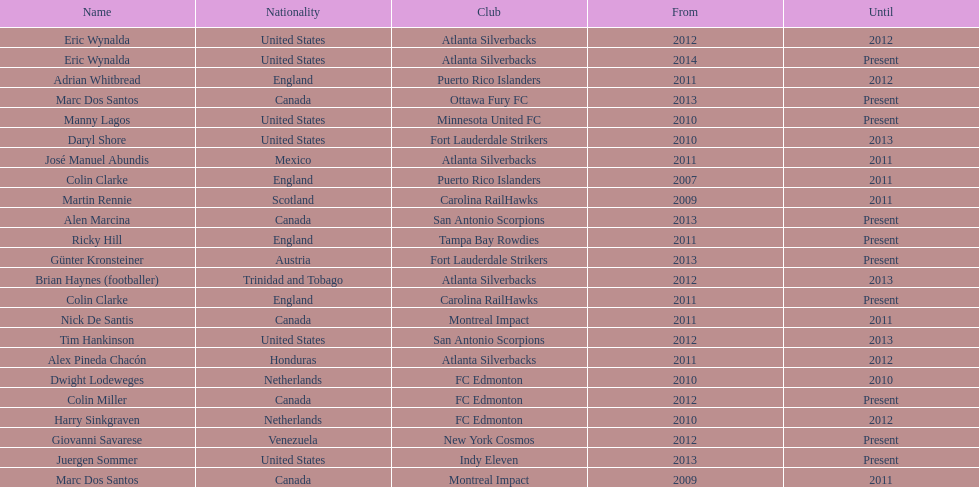What same country did marc dos santos coach as colin miller? Canada. 